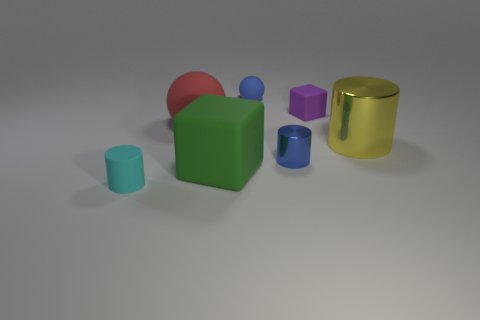Subtract all small cylinders. How many cylinders are left? 1 Add 2 large yellow matte balls. How many objects exist? 9 Subtract all cyan cylinders. How many cylinders are left? 2 Subtract all purple cylinders. Subtract all blue balls. How many cylinders are left? 3 Subtract all spheres. How many objects are left? 5 Subtract all red rubber balls. Subtract all small purple cubes. How many objects are left? 5 Add 6 rubber cylinders. How many rubber cylinders are left? 7 Add 6 large red matte balls. How many large red matte balls exist? 7 Subtract 0 yellow blocks. How many objects are left? 7 